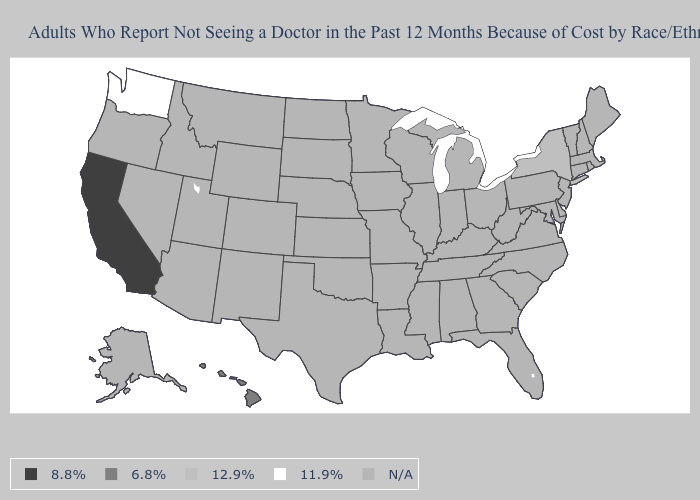What is the value of Kentucky?
Concise answer only. N/A. Which states have the highest value in the USA?
Give a very brief answer. California. What is the value of Alabama?
Concise answer only. N/A. Name the states that have a value in the range 6.8%?
Concise answer only. Hawaii. What is the value of Iowa?
Concise answer only. N/A. Among the states that border Massachusetts , which have the lowest value?
Quick response, please. New York. What is the highest value in the USA?
Give a very brief answer. 8.8%. What is the highest value in the USA?
Keep it brief. 8.8%. What is the value of Minnesota?
Short answer required. N/A. What is the value of West Virginia?
Give a very brief answer. N/A. Name the states that have a value in the range 6.8%?
Write a very short answer. Hawaii. Name the states that have a value in the range 12.9%?
Be succinct. New York. Name the states that have a value in the range N/A?
Be succinct. Alabama, Alaska, Arizona, Arkansas, Colorado, Connecticut, Delaware, Florida, Georgia, Idaho, Illinois, Indiana, Iowa, Kansas, Kentucky, Louisiana, Maine, Maryland, Massachusetts, Michigan, Minnesota, Mississippi, Missouri, Montana, Nebraska, Nevada, New Hampshire, New Jersey, New Mexico, North Carolina, North Dakota, Ohio, Oklahoma, Oregon, Pennsylvania, Rhode Island, South Carolina, South Dakota, Tennessee, Texas, Utah, Vermont, Virginia, West Virginia, Wisconsin, Wyoming. 